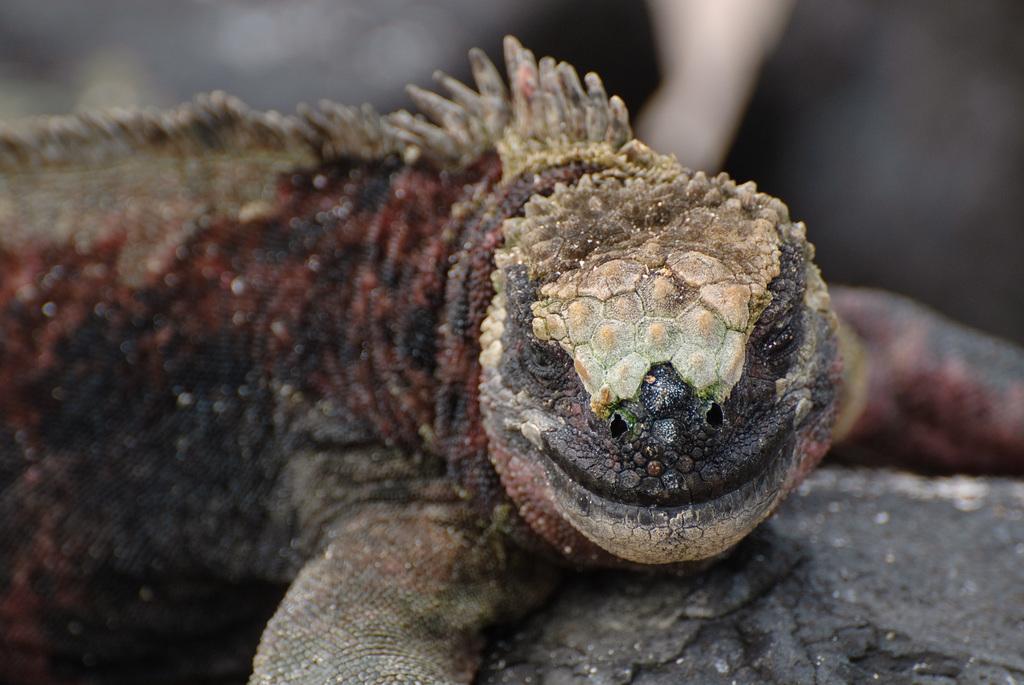Describe this image in one or two sentences. In this picture there is a gila monster on the wood. At the top it might be trees. 